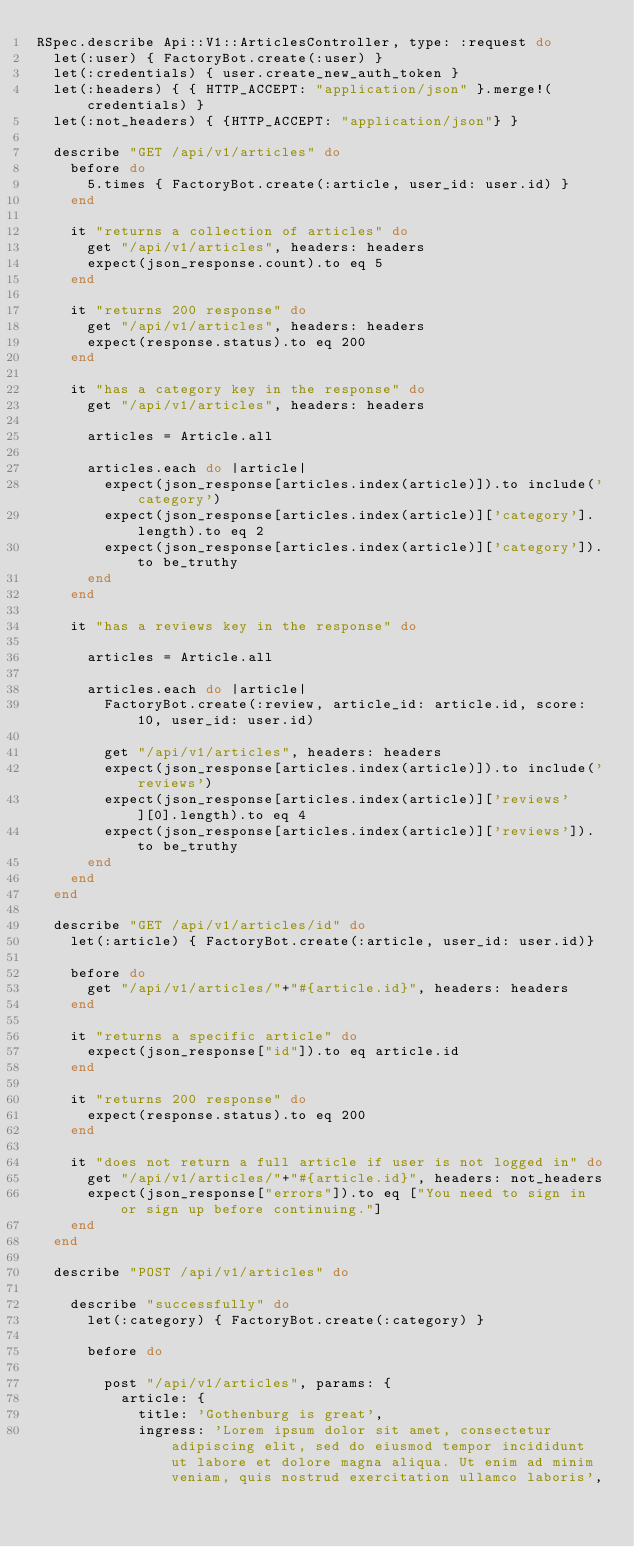<code> <loc_0><loc_0><loc_500><loc_500><_Ruby_>RSpec.describe Api::V1::ArticlesController, type: :request do
  let(:user) { FactoryBot.create(:user) }
  let(:credentials) { user.create_new_auth_token }
  let(:headers) { { HTTP_ACCEPT: "application/json" }.merge!(credentials) }
  let(:not_headers) { {HTTP_ACCEPT: "application/json"} }

  describe "GET /api/v1/articles" do
    before do
      5.times { FactoryBot.create(:article, user_id: user.id) }
    end

    it "returns a collection of articles" do
      get "/api/v1/articles", headers: headers
      expect(json_response.count).to eq 5
    end

    it "returns 200 response" do
      get "/api/v1/articles", headers: headers
      expect(response.status).to eq 200
    end
    
    it "has a category key in the response" do
      get "/api/v1/articles", headers: headers

      articles = Article.all
      
      articles.each do |article|
        expect(json_response[articles.index(article)]).to include('category')
        expect(json_response[articles.index(article)]['category'].length).to eq 2
        expect(json_response[articles.index(article)]['category']).to be_truthy
      end
    end
    
    it "has a reviews key in the response" do

      articles = Article.all

      articles.each do |article|
        FactoryBot.create(:review, article_id: article.id, score: 10, user_id: user.id)

        get "/api/v1/articles", headers: headers
        expect(json_response[articles.index(article)]).to include('reviews')
        expect(json_response[articles.index(article)]['reviews'][0].length).to eq 4
        expect(json_response[articles.index(article)]['reviews']).to be_truthy
      end
    end
  end

  describe "GET /api/v1/articles/id" do
    let(:article) { FactoryBot.create(:article, user_id: user.id)}

    before do
      get "/api/v1/articles/"+"#{article.id}", headers: headers
    end

    it "returns a specific article" do
      expect(json_response["id"]).to eq article.id
    end

    it "returns 200 response" do
      expect(response.status).to eq 200
    end

    it "does not return a full article if user is not logged in" do
      get "/api/v1/articles/"+"#{article.id}", headers: not_headers
      expect(json_response["errors"]).to eq ["You need to sign in or sign up before continuing."]
    end
  end

  describe "POST /api/v1/articles" do

    describe "successfully" do
      let(:category) { FactoryBot.create(:category) }
  
      before do

        post "/api/v1/articles", params: {
          article: {
            title: 'Gothenburg is great',
            ingress: 'Lorem ipsum dolor sit amet, consectetur adipiscing elit, sed do eiusmod tempor incididunt ut labore et dolore magna aliqua. Ut enim ad minim veniam, quis nostrud exercitation ullamco laboris',</code> 